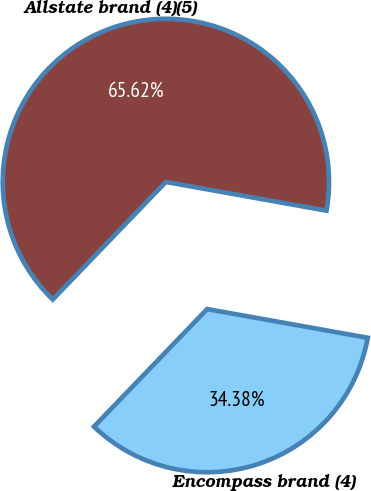<chart> <loc_0><loc_0><loc_500><loc_500><pie_chart><fcel>Allstate brand (4)(5)<fcel>Encompass brand (4)<nl><fcel>65.62%<fcel>34.38%<nl></chart> 